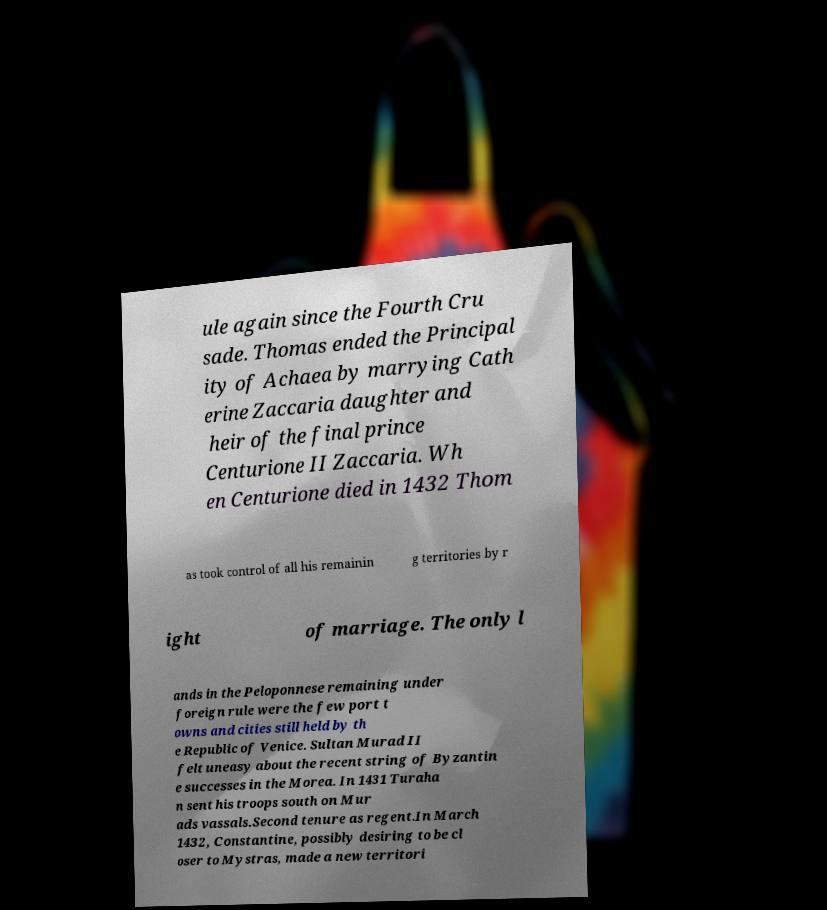What messages or text are displayed in this image? I need them in a readable, typed format. ule again since the Fourth Cru sade. Thomas ended the Principal ity of Achaea by marrying Cath erine Zaccaria daughter and heir of the final prince Centurione II Zaccaria. Wh en Centurione died in 1432 Thom as took control of all his remainin g territories by r ight of marriage. The only l ands in the Peloponnese remaining under foreign rule were the few port t owns and cities still held by th e Republic of Venice. Sultan Murad II felt uneasy about the recent string of Byzantin e successes in the Morea. In 1431 Turaha n sent his troops south on Mur ads vassals.Second tenure as regent.In March 1432, Constantine, possibly desiring to be cl oser to Mystras, made a new territori 